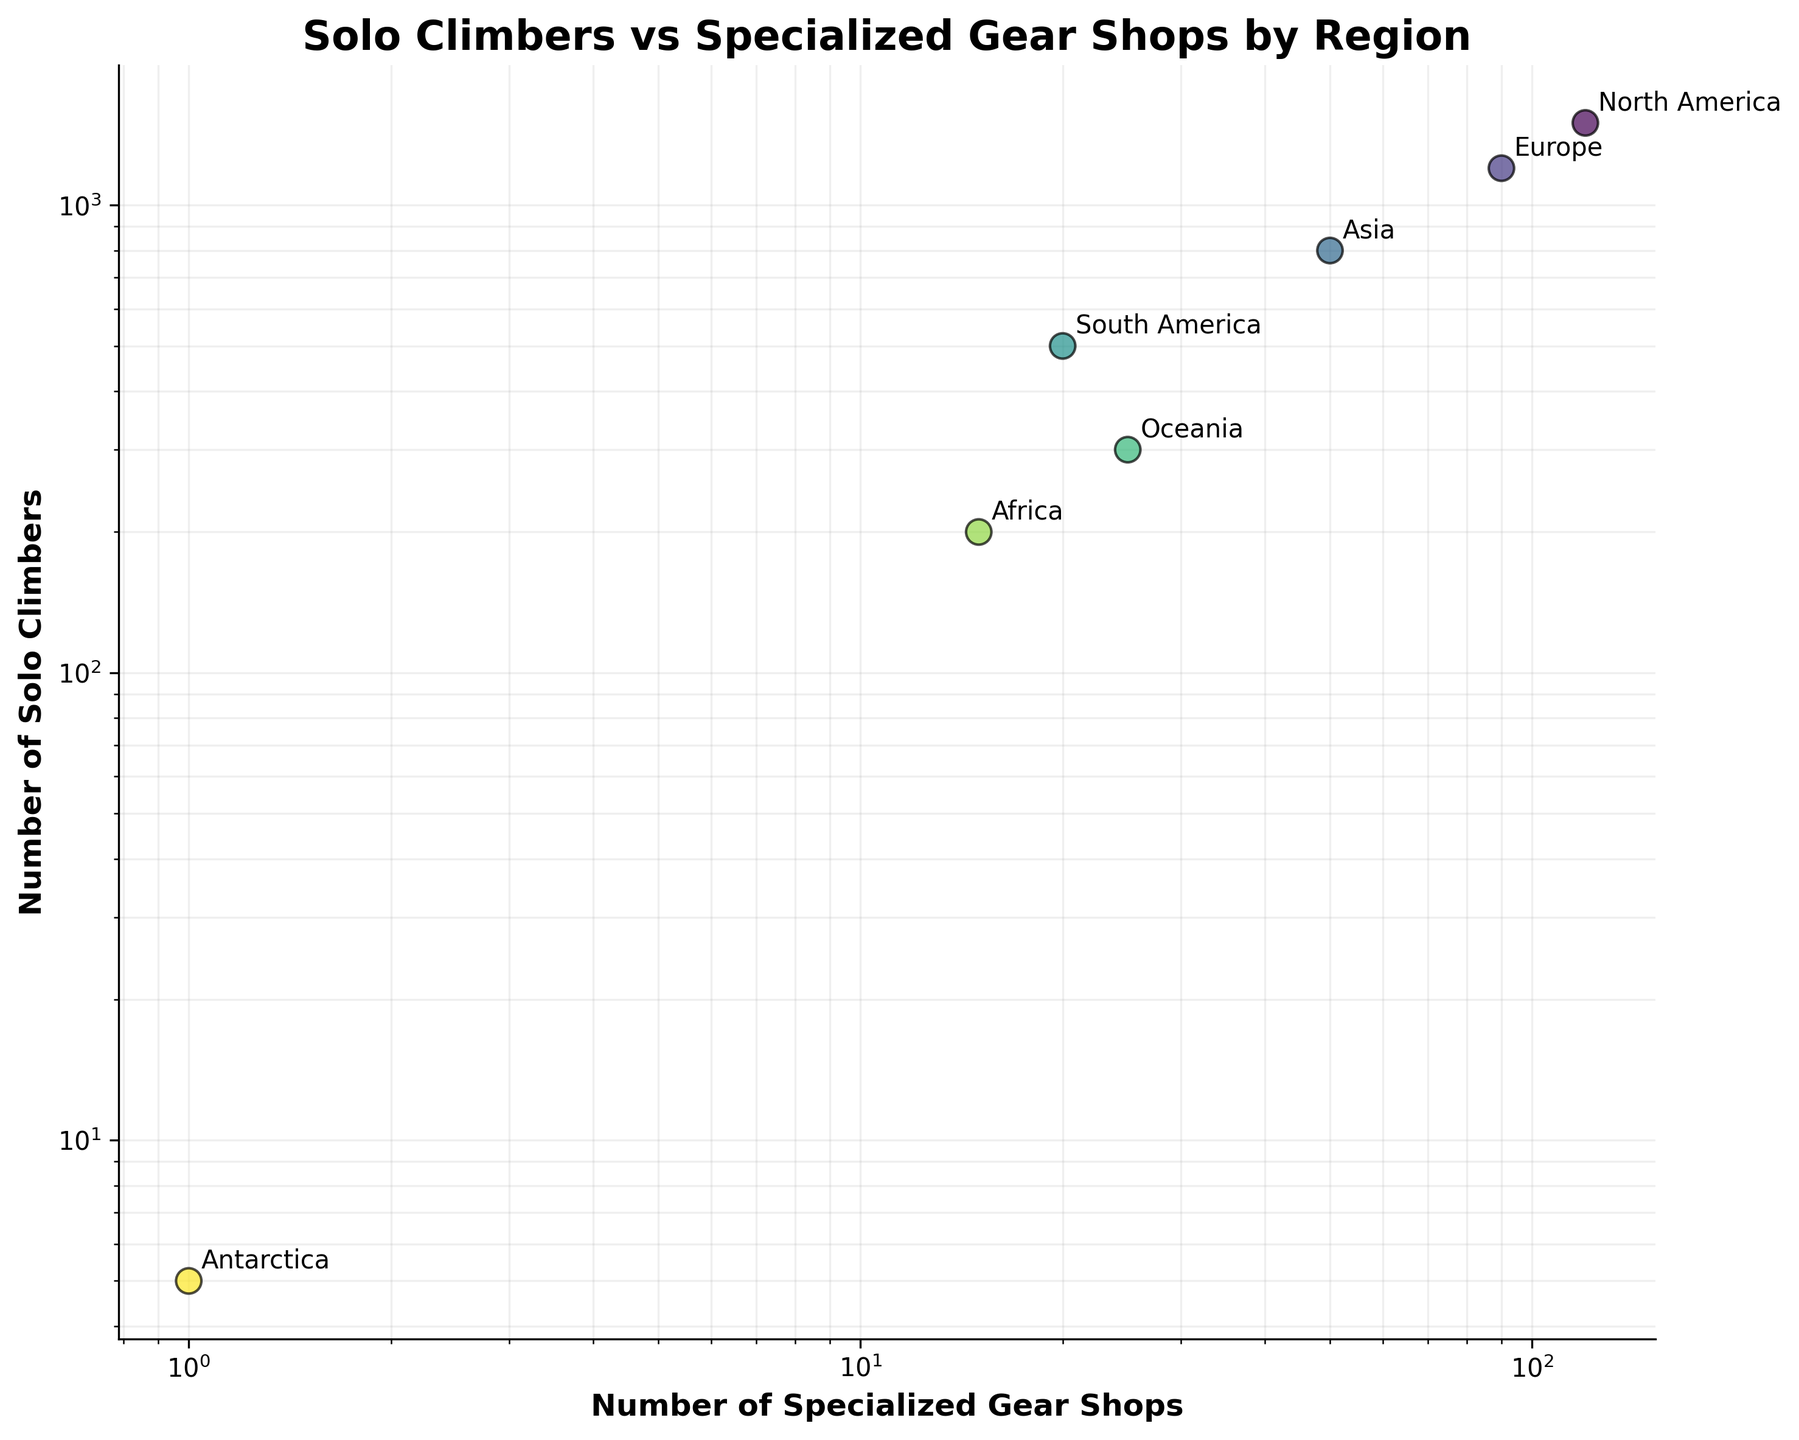What is the title of the figure? The title of the figure is displayed at the top, summarizing the main idea of the plot. It helps the viewer understand the content at a glance.
Answer: Solo Climbers vs Specialized Gear Shops by Region How many regions are represented in the figure? Count the number of distinct data points (each with a label) in the figure. One data point corresponds to one region.
Answer: 7 Which region has the highest number of solo climbers? Look for the data point with the highest y-coordinate on the scatter plot.
Answer: North America Which region has the lowest number of specialized gear shops? Identify the data point closest to the origin on the x-axis by looking for the lowest x-coordinate.
Answer: Antarctica What is the approximate ratio of solo climbers to specialized gear shops for Europe? Find the data point labeled 'Europe' and divide the y-coordinate (number of solo climbers) by the x-coordinate (number of specialized gear shops). 1200 climbers / 90 shops = 13.33.
Answer: 13.33 Which regions have fewer than 50 specialized gear shops? Identify data points where the x-coordinate (specialized gear shops) is less than 50.
Answer: Asia, South America, Africa, Antarctica Which region shows the greatest disparity between the number of solo climbers and specialized gear shops? Calculate the difference (disparity) for each region by subtracting the number of specialized gear shops from the number of solo climbers and find the highest value. North America: 1500-120=1380, Europe: 1200-90=1110, etc.
Answer: North America Are there any regions where the number of specialized gear shops is greater than the number of solo climbers? Compare the x-coordinates (shops) and y-coordinates (climbers) of each data point. Check if any have more specialized gear shops than solo climbers.
Answer: No Which region has the second-highest number of solo climbers, and what is that number? Order the data points based on their y-coordinate and identify the second highest value.
Answer: Europe, 1200 What pattern or trend can be observed between the number of solo climbers and the number of specialized gear shops? Examine the overall distribution of data points in the scatter plot. Observe how the number of solo climbers changes with the number of specialized gear shops. Generally, regions with more specialized gear shops have more solo climbers.
Answer: More gear shops, more climbers 